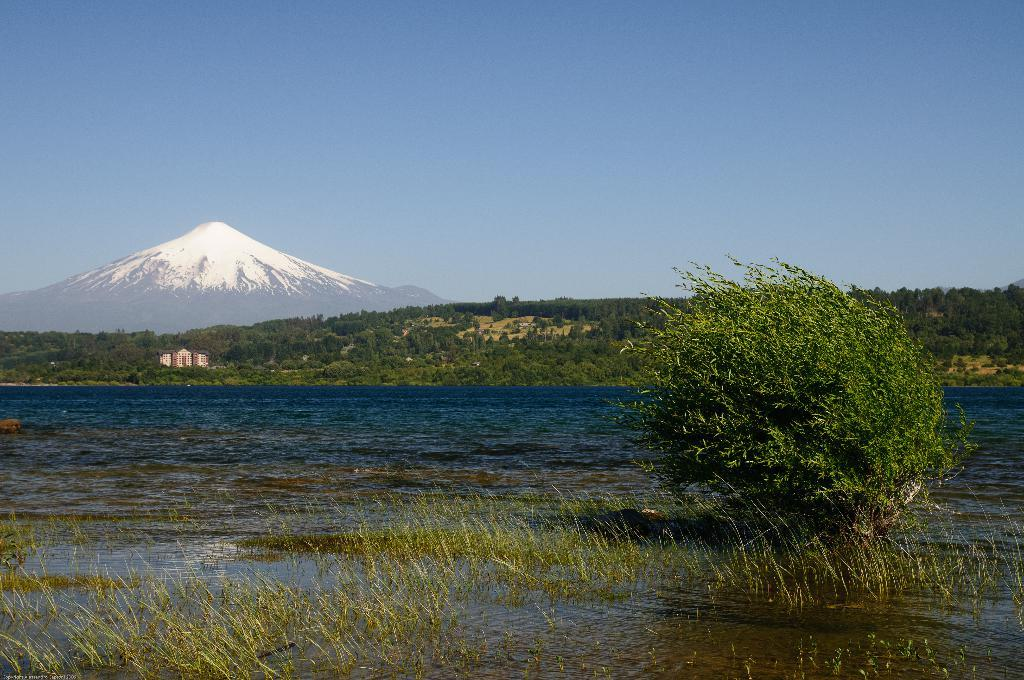What type of natural environment is depicted in the image? The image contains water, grass, plants, trees, and a mountain, which are all elements of a natural environment. What type of ground can be seen in the image? The ground is visible in the image, and it appears to be grassy. What man-made structures are present in the image? There are buildings in the image. What is visible in the sky in the image? The sky is visible in the image. What level of experience does the doctor have in designing beginner-friendly software in the image? There is no doctor or software design present in the image; it features a natural landscape with water, grass, plants, trees, a mountain, buildings, and the sky. 